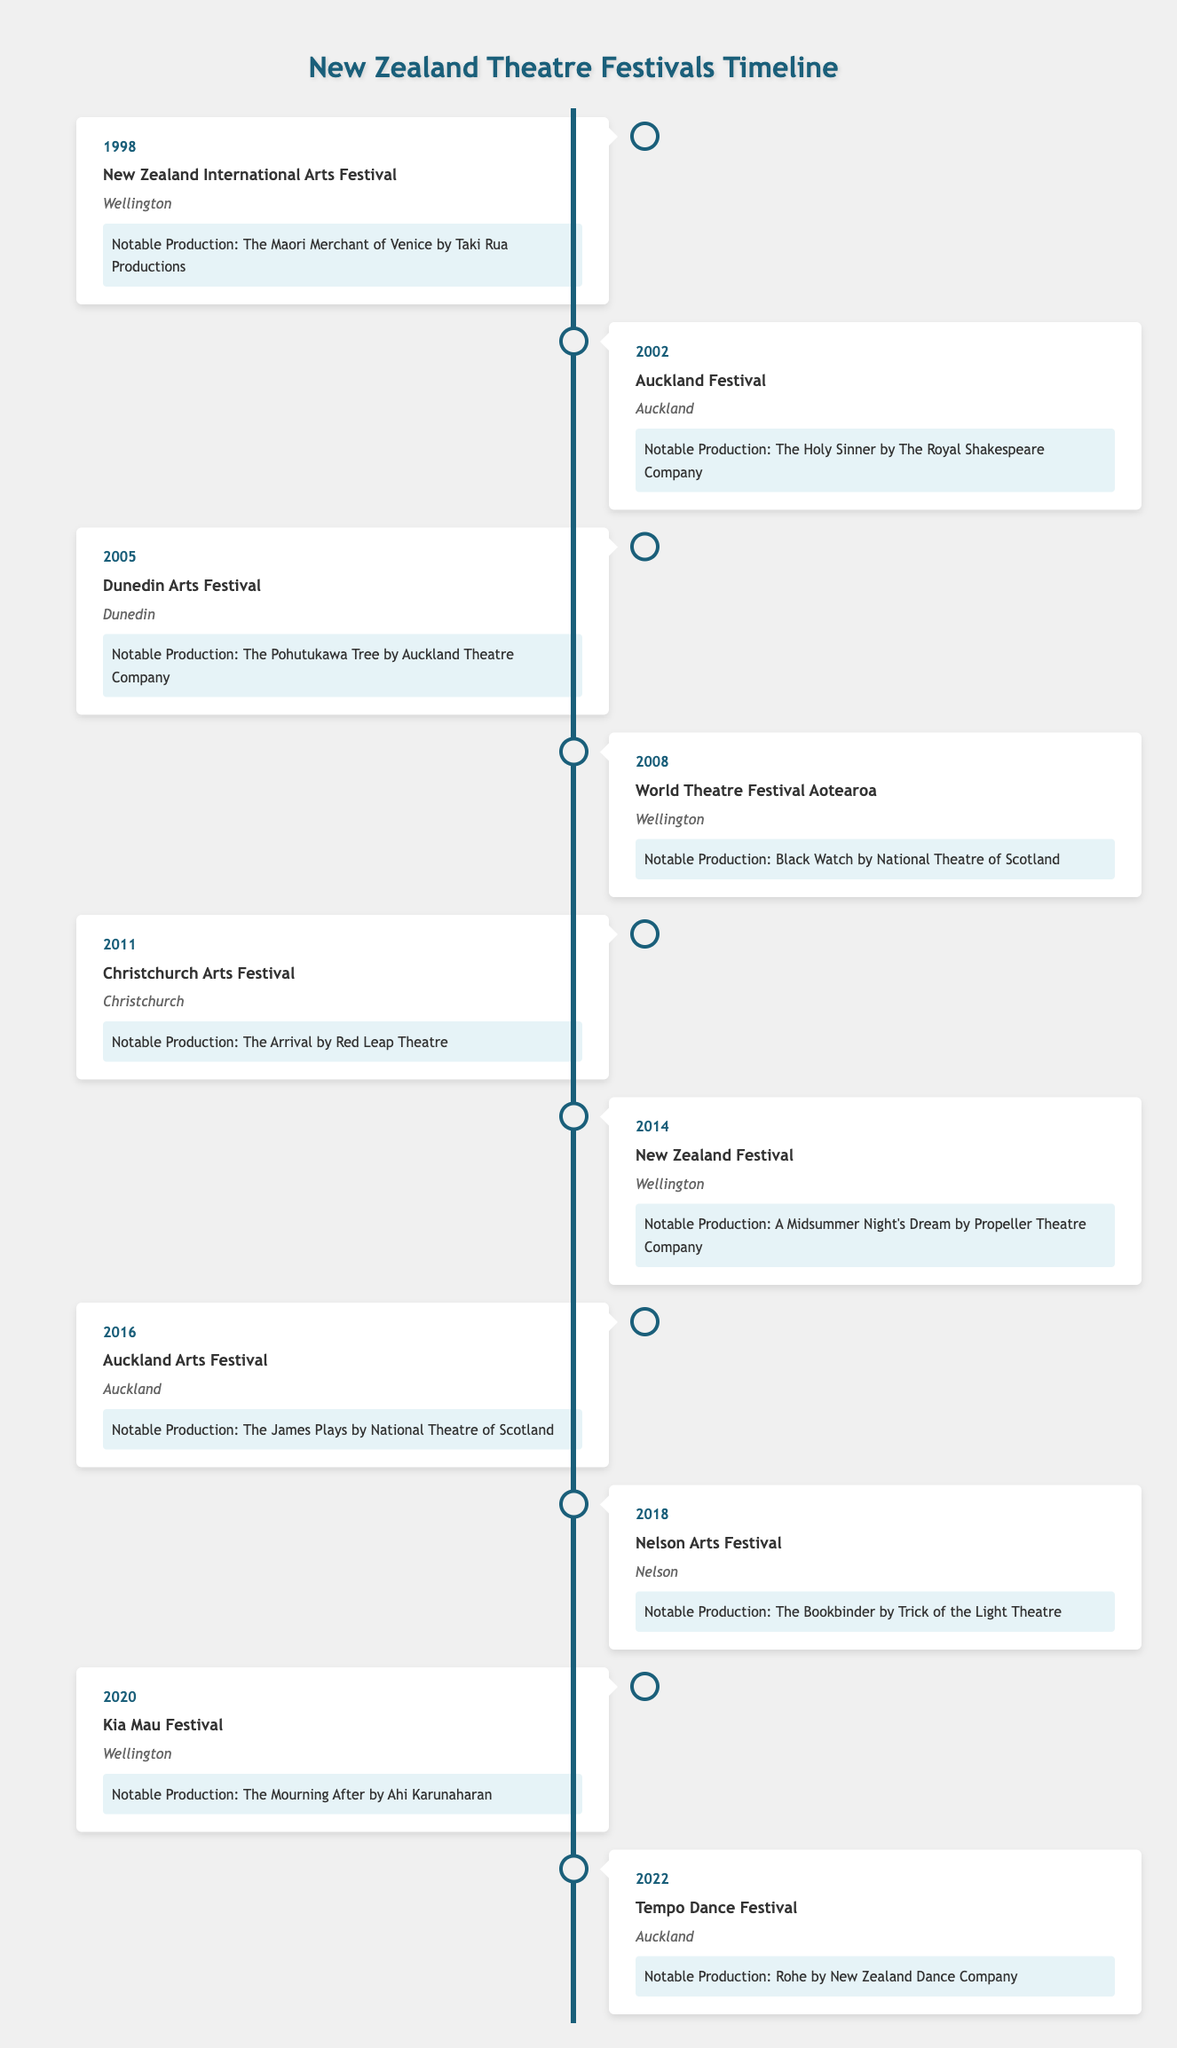What is the location of the Dunedin Arts Festival? The table indicates that the Dunedin Arts Festival is listed under the year 2005, and its corresponding location is specified as Dunedin. Therefore, the answer is Dunedin.
Answer: Dunedin What notable production was featured at the New Zealand Festival in 2014? The table shows that in the year 2014, the event listed is the New Zealand Festival, and the notable production associated with this event is A Midsummer Night's Dream by Propeller Theatre Company.
Answer: A Midsummer Night's Dream by Propeller Theatre Company How many festivals were hosted in Wellington? By examining the table, we can identify the events hosted in Wellington: the New Zealand International Arts Festival (1998), the World Theatre Festival Aotearoa (2008), the New Zealand Festival (2014), and the Kia Mau Festival (2020). Counting these gives us a total of four festivals hosted in Wellington.
Answer: 4 Is there a festival that featured a production by the National Theatre of Scotland? Looking through the table, the productions associated with the National Theatre of Scotland are Black Watch (in 2008) and The James Plays (in 2016). Since both these events are hosted at different festivals, the answer is yes, there are festivals featuring productions by the National Theatre of Scotland.
Answer: Yes Which festival had the earliest occurrence and what was its notable production? The earliest event listed in the table is the New Zealand International Arts Festival, which occurred in 1998. The notable production for this festival is The Maori Merchant of Venice by Taki Rua Productions.
Answer: New Zealand International Arts Festival, The Maori Merchant of Venice by Taki Rua Productions How many years passed between the Auckland Festival in 2002 and the Tempo Dance Festival in 2022? To find the number of years between these two festivals, we subtract the years: 2022 - 2002 = 20 years. Therefore, there are 20 years that passed between the Auckland Festival and the Tempo Dance Festival.
Answer: 20 years Were there more festivals held in Auckland than in other cities combined? Based on the table, Auckland has hosted three festivals (Auckland Festival, Auckland Arts Festival, Tempo Dance Festival), while Wellington has four and Dunedin and Christchurch have one each. In total, Wellington (4), plus Dunedin and Christchurch (1 each) combined gives us 6 festivals. Since there are three in Auckland, the answer is no.
Answer: No What notable productions were featured in the Christchurch Arts Festival and the Kia Mau Festival? The table shows that the Christchurch Arts Festival featured The Arrival by Red Leap Theatre in 2011, while the Kia Mau Festival featured The Mourning After by Ahi Karunaharan in 2020. Therefore, the notable productions for the two festivals are The Arrival by Red Leap Theatre and The Mourning After by Ahi Karunaharan.
Answer: The Arrival by Red Leap Theatre, The Mourning After by Ahi Karunaharan 